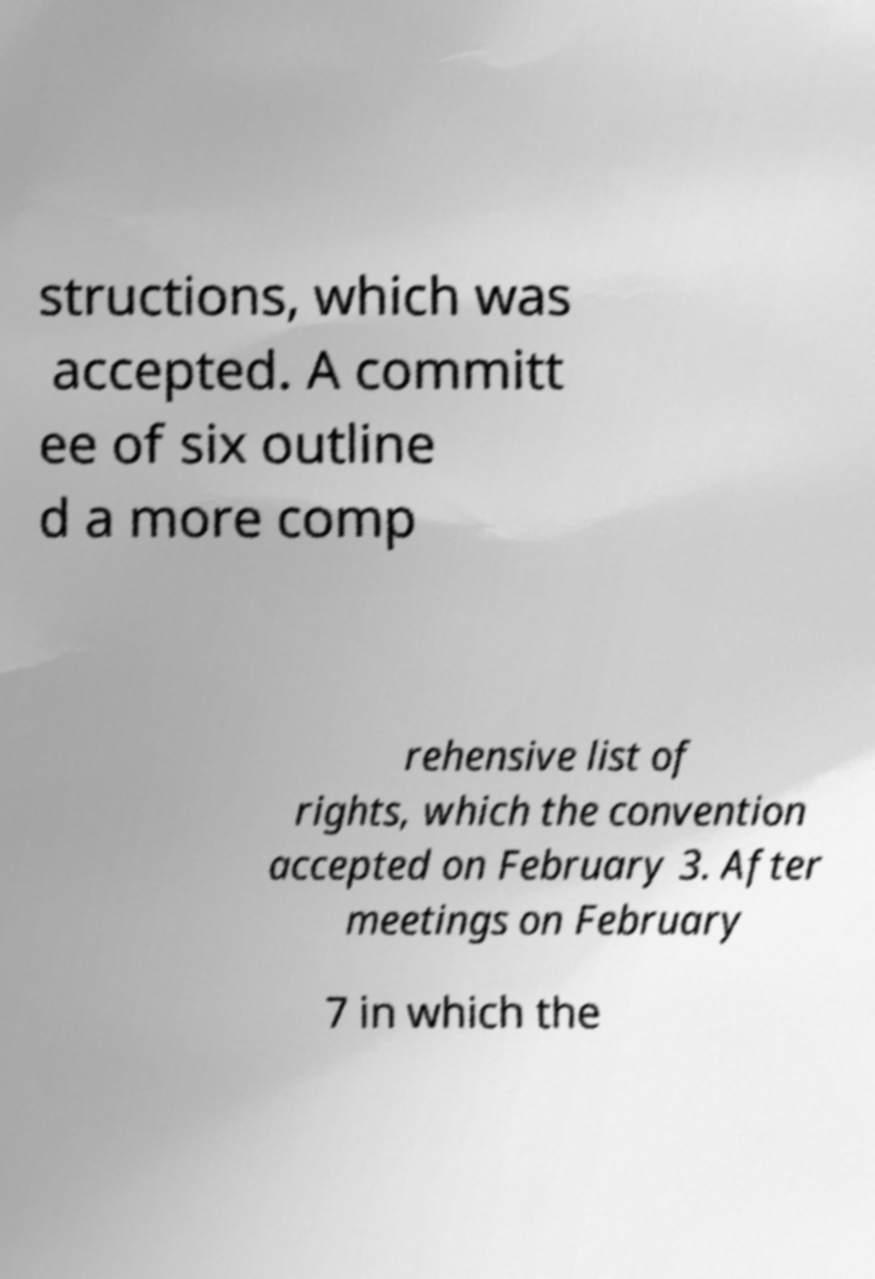Could you assist in decoding the text presented in this image and type it out clearly? structions, which was accepted. A committ ee of six outline d a more comp rehensive list of rights, which the convention accepted on February 3. After meetings on February 7 in which the 